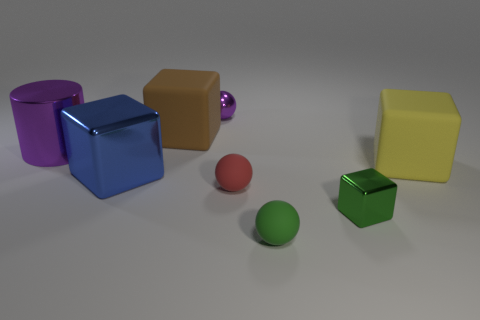Subtract 1 cubes. How many cubes are left? 3 Subtract all red spheres. How many spheres are left? 2 Add 1 purple metal cylinders. How many objects exist? 9 Subtract all cylinders. How many objects are left? 7 Subtract 1 blue blocks. How many objects are left? 7 Subtract all tiny red things. Subtract all large yellow objects. How many objects are left? 6 Add 1 purple metallic cylinders. How many purple metallic cylinders are left? 2 Add 7 purple spheres. How many purple spheres exist? 8 